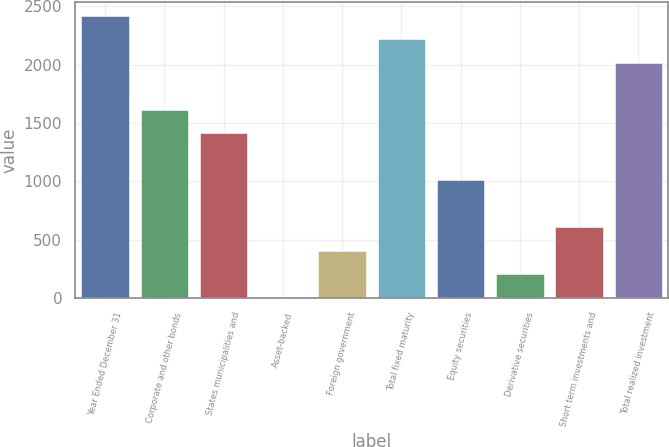Convert chart. <chart><loc_0><loc_0><loc_500><loc_500><bar_chart><fcel>Year Ended December 31<fcel>Corporate and other bonds<fcel>States municipalities and<fcel>Asset-backed<fcel>Foreign government<fcel>Total fixed maturity<fcel>Equity securities<fcel>Derivative securities<fcel>Short term investments and<fcel>Total realized investment<nl><fcel>2418.8<fcel>1613.2<fcel>1411.8<fcel>2<fcel>404.8<fcel>2217.4<fcel>1009<fcel>203.4<fcel>606.2<fcel>2016<nl></chart> 